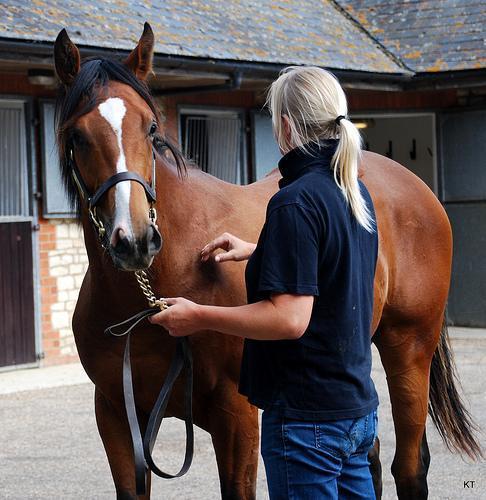How many people are in the picture?
Give a very brief answer. 1. 